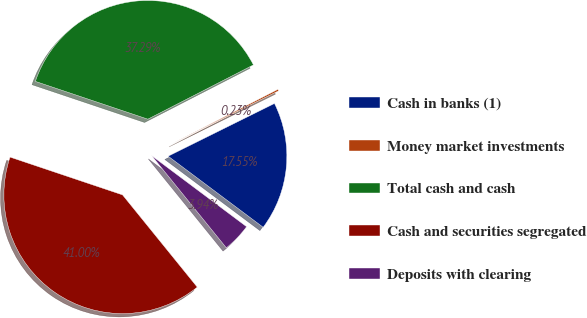<chart> <loc_0><loc_0><loc_500><loc_500><pie_chart><fcel>Cash in banks (1)<fcel>Money market investments<fcel>Total cash and cash<fcel>Cash and securities segregated<fcel>Deposits with clearing<nl><fcel>17.55%<fcel>0.23%<fcel>37.29%<fcel>41.0%<fcel>3.94%<nl></chart> 